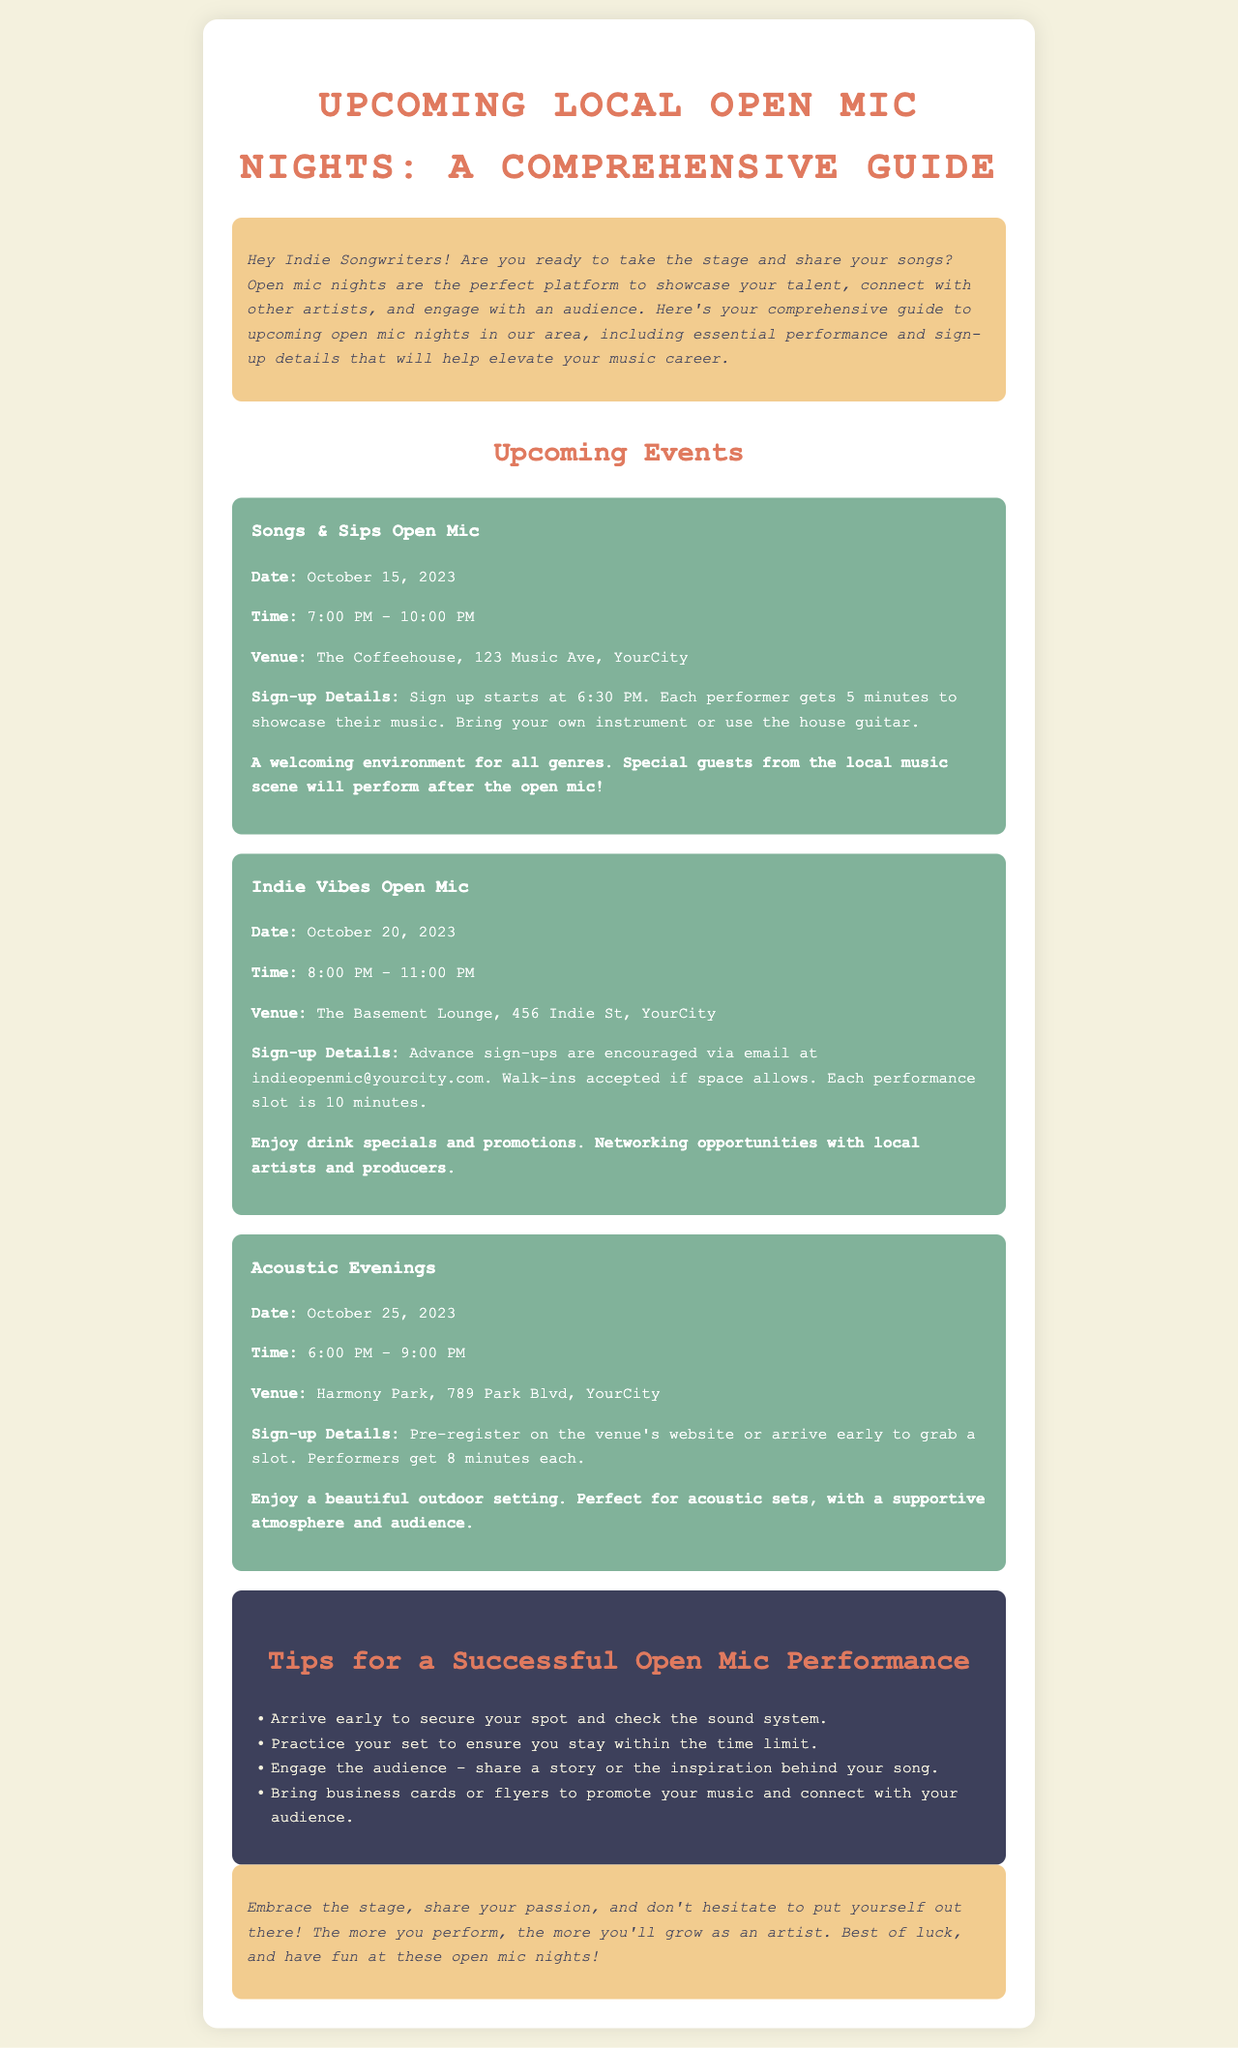What is the date of the Songs & Sips Open Mic? The date for the Songs & Sips Open Mic is explicitly stated in the document as October 15, 2023.
Answer: October 15, 2023 How long is each performance slot at the Indie Vibes Open Mic? The document specifies that each performance slot at the Indie Vibes Open Mic is 10 minutes long.
Answer: 10 minutes Where is the Acoustic Evenings open mic held? The location for the Acoustic Evenings event is provided as Harmony Park, 789 Park Blvd, YourCity in the document.
Answer: Harmony Park, 789 Park Blvd, YourCity What time do sign-ups start for the Songs & Sips Open Mic? The document mentions that sign up starts at 6:30 PM for the Songs & Sips Open Mic.
Answer: 6:30 PM What is one benefit of participating in the Indie Vibes Open Mic? The document highlights that participants can enjoy drink specials and promotions as a benefit of attending the Indie Vibes Open Mic.
Answer: Drink specials How can performers sign up for the Acoustic Evenings event? The document states that performers can pre-register on the venue's website or arrive early to grab a slot for the Acoustic Evenings.
Answer: Pre-register or arrive early What is a key tip mentioned for a successful open mic performance? The document lists several tips, one being to arrive early to secure a spot and check the sound system.
Answer: Arrive early What genre of music is welcome at the Songs & Sips Open Mic? The document indicates that a welcoming environment for all genres is emphasized for the Songs & Sips Open Mic.
Answer: All genres What is the venue for the Indie Vibes Open Mic? The venue for the Indie Vibes Open Mic is noted in the document as The Basement Lounge, 456 Indie St, YourCity.
Answer: The Basement Lounge, 456 Indie St, YourCity 